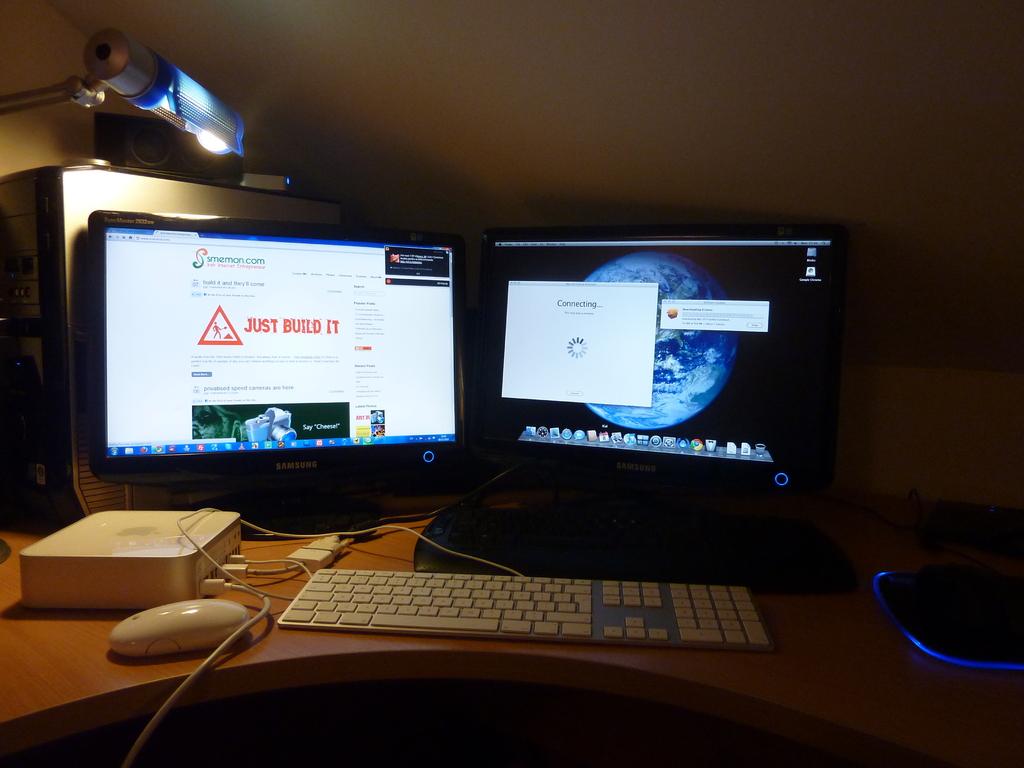Just build what?
Give a very brief answer. It. 